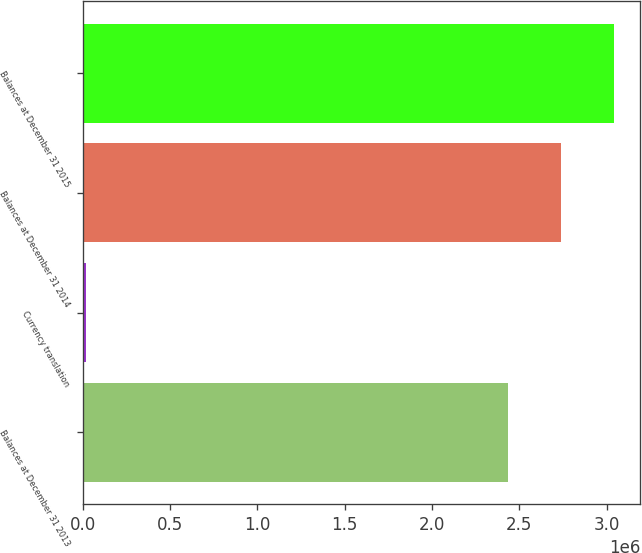Convert chart to OTSL. <chart><loc_0><loc_0><loc_500><loc_500><bar_chart><fcel>Balances at December 31 2013<fcel>Currency translation<fcel>Balances at December 31 2014<fcel>Balances at December 31 2015<nl><fcel>2.43551e+06<fcel>18847<fcel>2.73754e+06<fcel>3.03958e+06<nl></chart> 